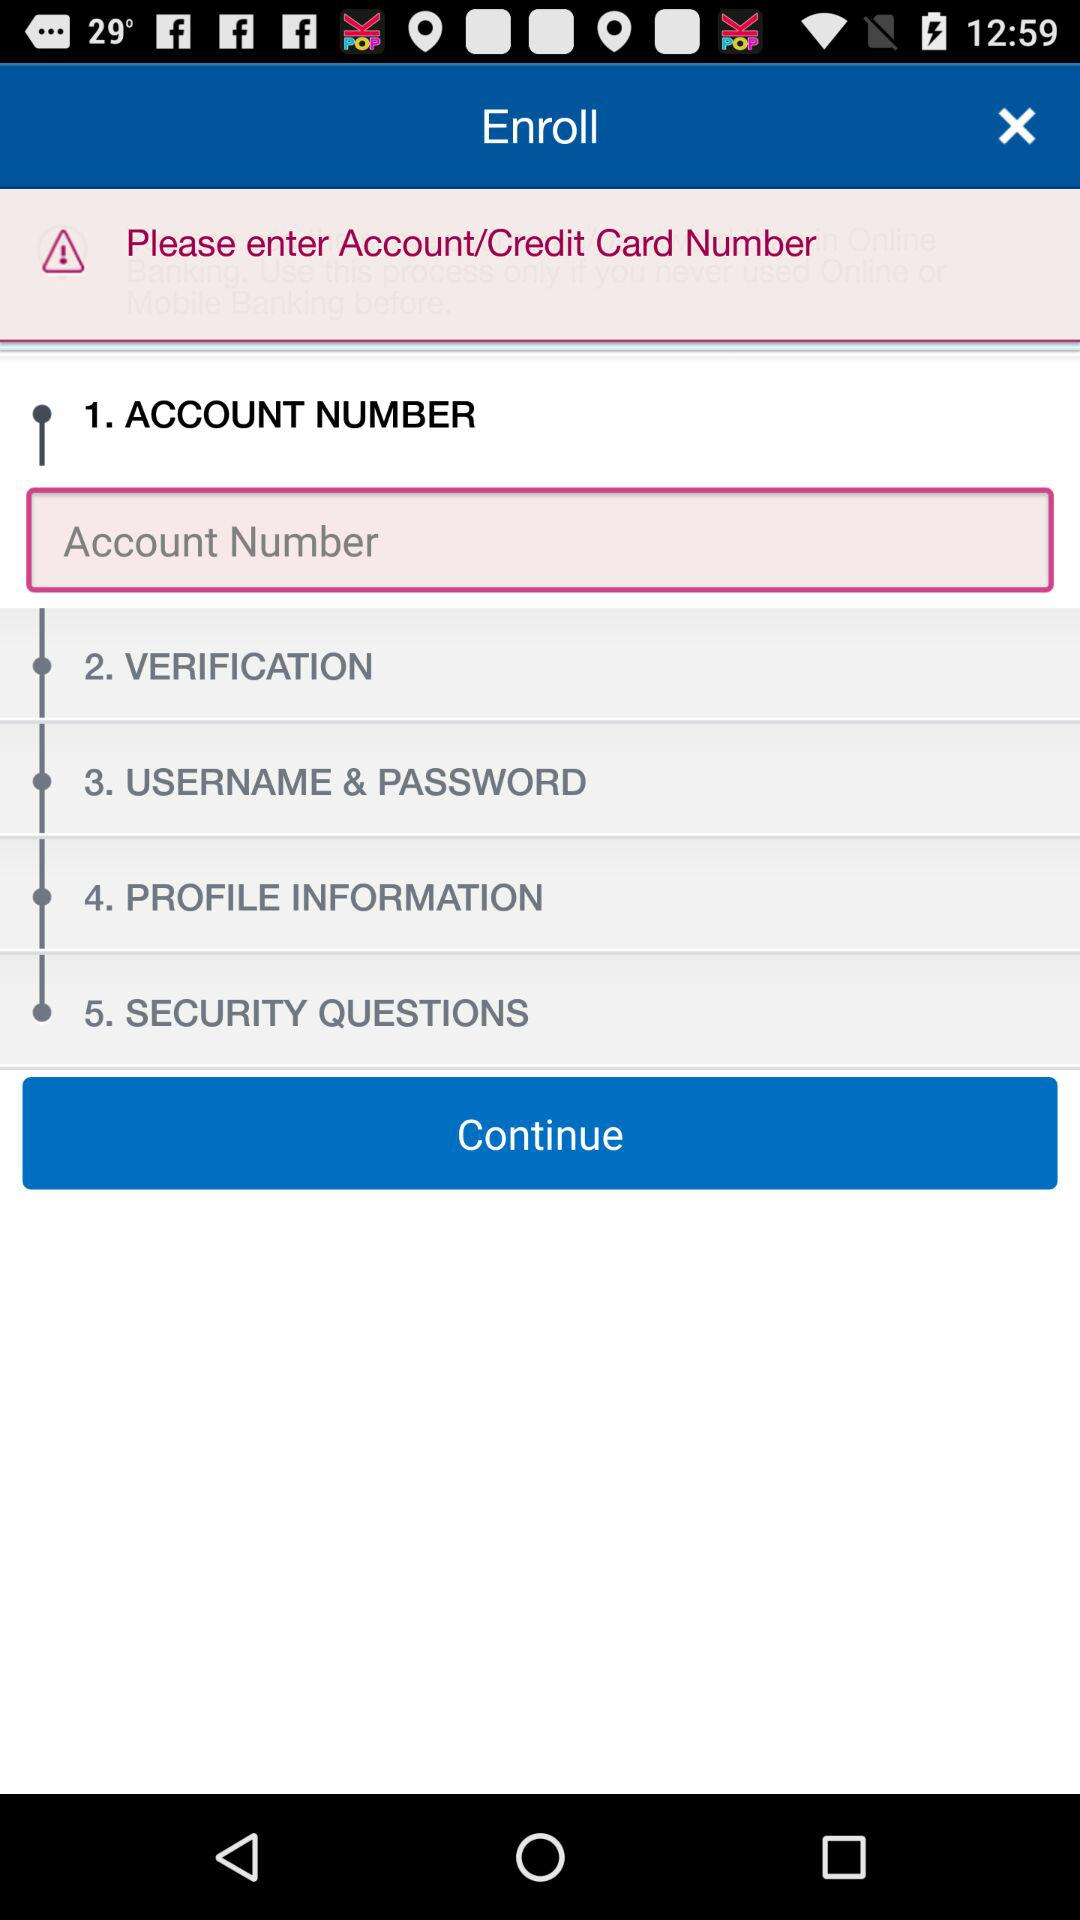What is the total number of steps? The total number of steps are 5. 